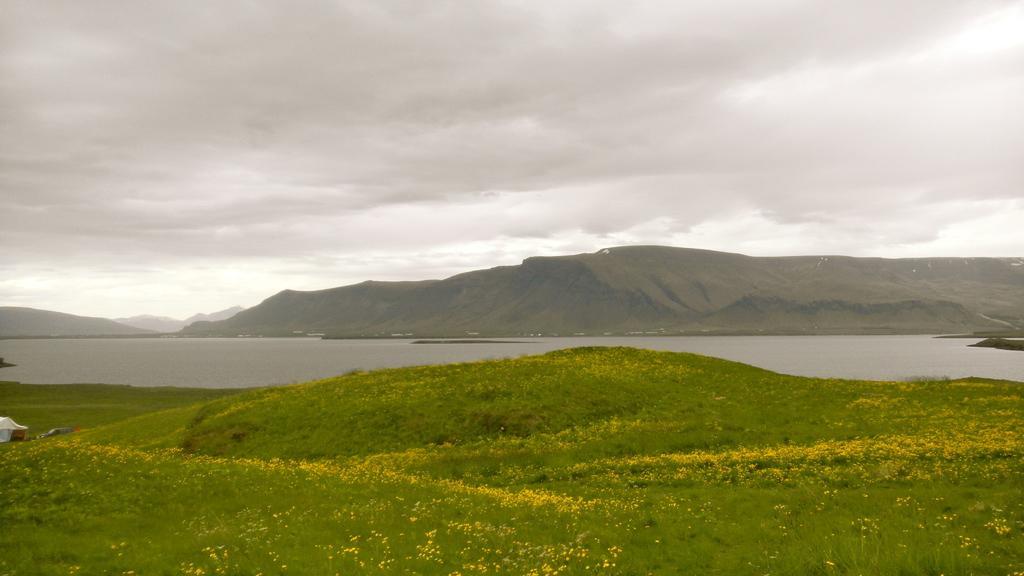Please provide a concise description of this image. In this image i can see some plants to which flowers are grown and in the background of the picture there is water, there are some mountains and cloudy sky. 